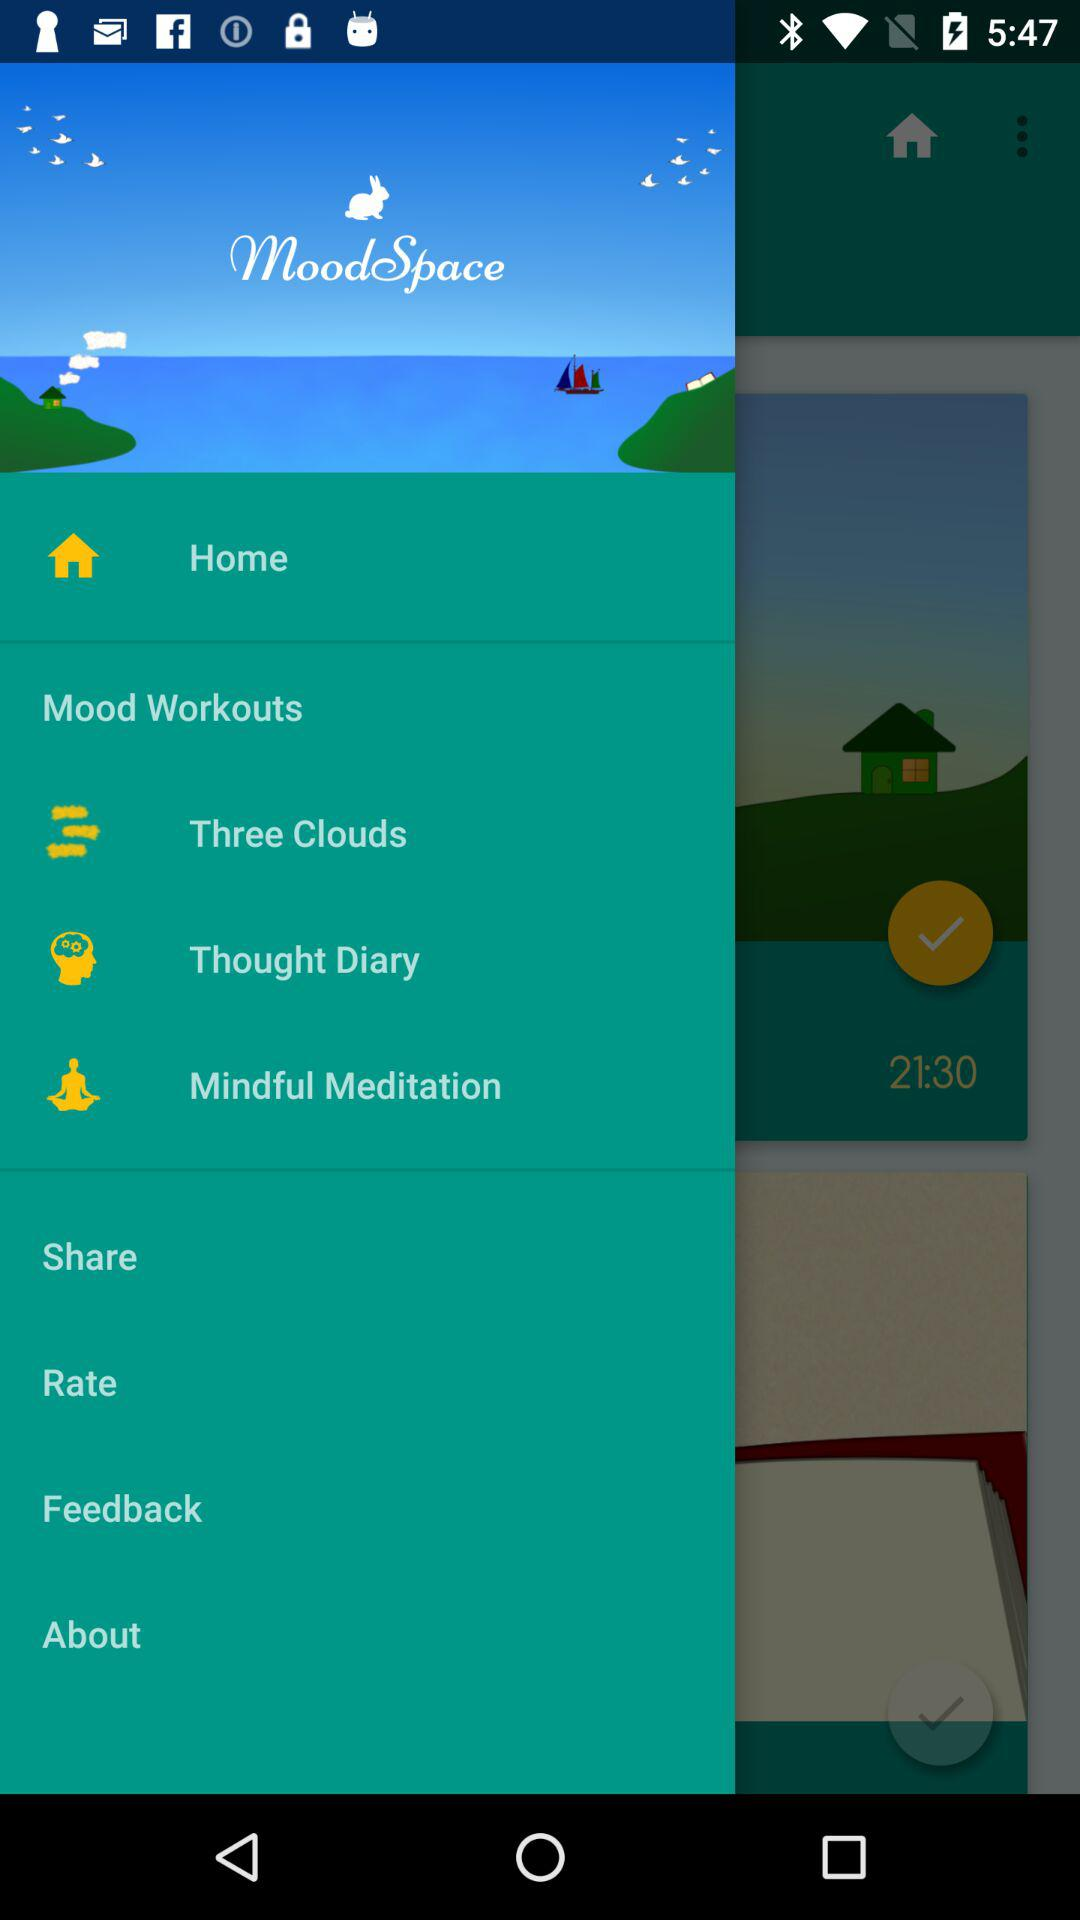How many notifications are there in "Rate"?
When the provided information is insufficient, respond with <no answer>. <no answer> 